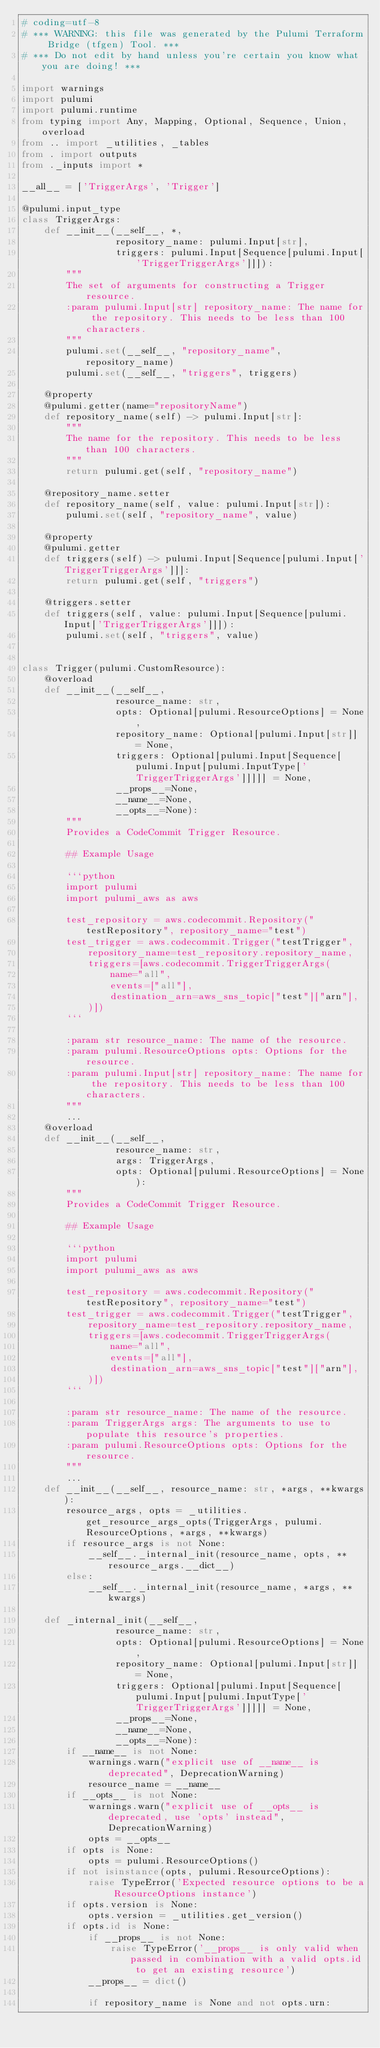<code> <loc_0><loc_0><loc_500><loc_500><_Python_># coding=utf-8
# *** WARNING: this file was generated by the Pulumi Terraform Bridge (tfgen) Tool. ***
# *** Do not edit by hand unless you're certain you know what you are doing! ***

import warnings
import pulumi
import pulumi.runtime
from typing import Any, Mapping, Optional, Sequence, Union, overload
from .. import _utilities, _tables
from . import outputs
from ._inputs import *

__all__ = ['TriggerArgs', 'Trigger']

@pulumi.input_type
class TriggerArgs:
    def __init__(__self__, *,
                 repository_name: pulumi.Input[str],
                 triggers: pulumi.Input[Sequence[pulumi.Input['TriggerTriggerArgs']]]):
        """
        The set of arguments for constructing a Trigger resource.
        :param pulumi.Input[str] repository_name: The name for the repository. This needs to be less than 100 characters.
        """
        pulumi.set(__self__, "repository_name", repository_name)
        pulumi.set(__self__, "triggers", triggers)

    @property
    @pulumi.getter(name="repositoryName")
    def repository_name(self) -> pulumi.Input[str]:
        """
        The name for the repository. This needs to be less than 100 characters.
        """
        return pulumi.get(self, "repository_name")

    @repository_name.setter
    def repository_name(self, value: pulumi.Input[str]):
        pulumi.set(self, "repository_name", value)

    @property
    @pulumi.getter
    def triggers(self) -> pulumi.Input[Sequence[pulumi.Input['TriggerTriggerArgs']]]:
        return pulumi.get(self, "triggers")

    @triggers.setter
    def triggers(self, value: pulumi.Input[Sequence[pulumi.Input['TriggerTriggerArgs']]]):
        pulumi.set(self, "triggers", value)


class Trigger(pulumi.CustomResource):
    @overload
    def __init__(__self__,
                 resource_name: str,
                 opts: Optional[pulumi.ResourceOptions] = None,
                 repository_name: Optional[pulumi.Input[str]] = None,
                 triggers: Optional[pulumi.Input[Sequence[pulumi.Input[pulumi.InputType['TriggerTriggerArgs']]]]] = None,
                 __props__=None,
                 __name__=None,
                 __opts__=None):
        """
        Provides a CodeCommit Trigger Resource.

        ## Example Usage

        ```python
        import pulumi
        import pulumi_aws as aws

        test_repository = aws.codecommit.Repository("testRepository", repository_name="test")
        test_trigger = aws.codecommit.Trigger("testTrigger",
            repository_name=test_repository.repository_name,
            triggers=[aws.codecommit.TriggerTriggerArgs(
                name="all",
                events=["all"],
                destination_arn=aws_sns_topic["test"]["arn"],
            )])
        ```

        :param str resource_name: The name of the resource.
        :param pulumi.ResourceOptions opts: Options for the resource.
        :param pulumi.Input[str] repository_name: The name for the repository. This needs to be less than 100 characters.
        """
        ...
    @overload
    def __init__(__self__,
                 resource_name: str,
                 args: TriggerArgs,
                 opts: Optional[pulumi.ResourceOptions] = None):
        """
        Provides a CodeCommit Trigger Resource.

        ## Example Usage

        ```python
        import pulumi
        import pulumi_aws as aws

        test_repository = aws.codecommit.Repository("testRepository", repository_name="test")
        test_trigger = aws.codecommit.Trigger("testTrigger",
            repository_name=test_repository.repository_name,
            triggers=[aws.codecommit.TriggerTriggerArgs(
                name="all",
                events=["all"],
                destination_arn=aws_sns_topic["test"]["arn"],
            )])
        ```

        :param str resource_name: The name of the resource.
        :param TriggerArgs args: The arguments to use to populate this resource's properties.
        :param pulumi.ResourceOptions opts: Options for the resource.
        """
        ...
    def __init__(__self__, resource_name: str, *args, **kwargs):
        resource_args, opts = _utilities.get_resource_args_opts(TriggerArgs, pulumi.ResourceOptions, *args, **kwargs)
        if resource_args is not None:
            __self__._internal_init(resource_name, opts, **resource_args.__dict__)
        else:
            __self__._internal_init(resource_name, *args, **kwargs)

    def _internal_init(__self__,
                 resource_name: str,
                 opts: Optional[pulumi.ResourceOptions] = None,
                 repository_name: Optional[pulumi.Input[str]] = None,
                 triggers: Optional[pulumi.Input[Sequence[pulumi.Input[pulumi.InputType['TriggerTriggerArgs']]]]] = None,
                 __props__=None,
                 __name__=None,
                 __opts__=None):
        if __name__ is not None:
            warnings.warn("explicit use of __name__ is deprecated", DeprecationWarning)
            resource_name = __name__
        if __opts__ is not None:
            warnings.warn("explicit use of __opts__ is deprecated, use 'opts' instead", DeprecationWarning)
            opts = __opts__
        if opts is None:
            opts = pulumi.ResourceOptions()
        if not isinstance(opts, pulumi.ResourceOptions):
            raise TypeError('Expected resource options to be a ResourceOptions instance')
        if opts.version is None:
            opts.version = _utilities.get_version()
        if opts.id is None:
            if __props__ is not None:
                raise TypeError('__props__ is only valid when passed in combination with a valid opts.id to get an existing resource')
            __props__ = dict()

            if repository_name is None and not opts.urn:</code> 